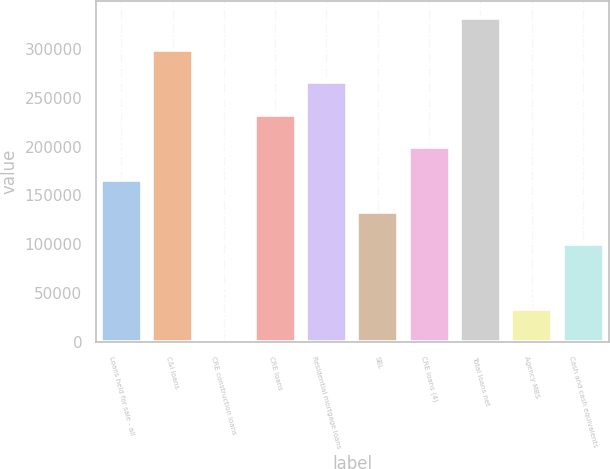Convert chart to OTSL. <chart><loc_0><loc_0><loc_500><loc_500><bar_chart><fcel>Loans held for sale - all<fcel>C&I loans<fcel>CRE construction loans<fcel>CRE loans<fcel>Residential mortgage loans<fcel>SBL<fcel>CRE loans (4)<fcel>Total loans net<fcel>Agency MBS<fcel>Cash and cash equivalents<nl><fcel>166196<fcel>298586<fcel>708<fcel>232390<fcel>265488<fcel>133098<fcel>199293<fcel>331683<fcel>33805.5<fcel>100000<nl></chart> 